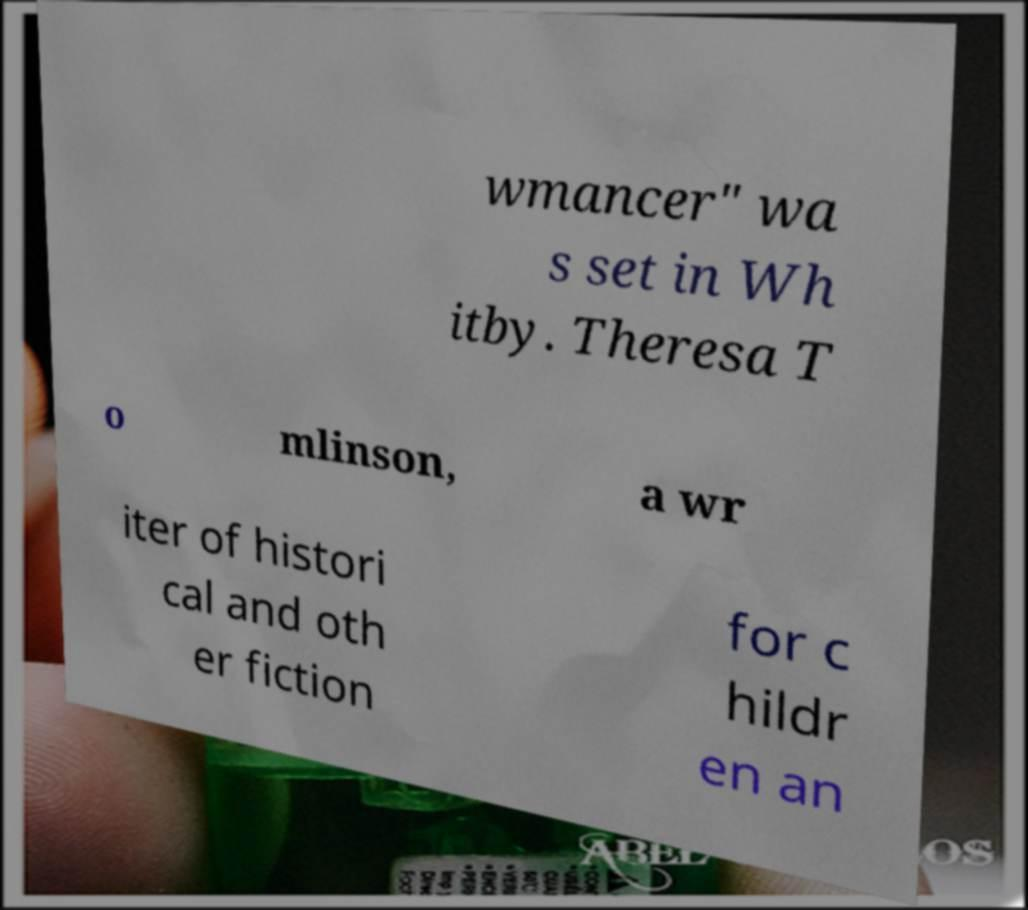Can you accurately transcribe the text from the provided image for me? wmancer" wa s set in Wh itby. Theresa T o mlinson, a wr iter of histori cal and oth er fiction for c hildr en an 